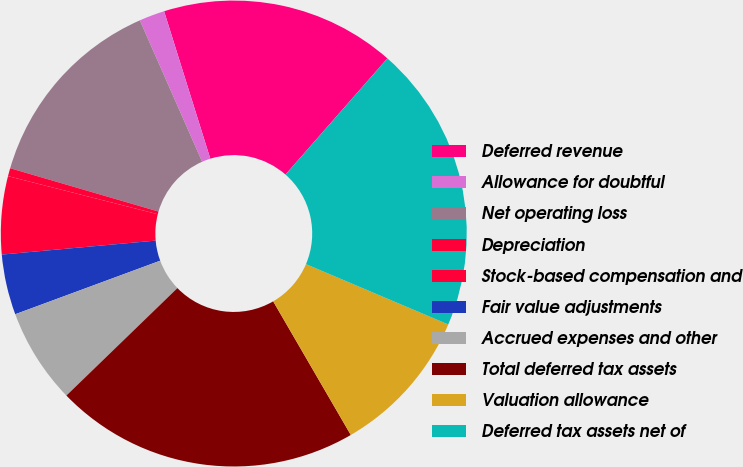Convert chart to OTSL. <chart><loc_0><loc_0><loc_500><loc_500><pie_chart><fcel>Deferred revenue<fcel>Allowance for doubtful<fcel>Net operating loss<fcel>Depreciation<fcel>Stock-based compensation and<fcel>Fair value adjustments<fcel>Accrued expenses and other<fcel>Total deferred tax assets<fcel>Valuation allowance<fcel>Deferred tax assets net of<nl><fcel>16.29%<fcel>1.77%<fcel>13.87%<fcel>0.56%<fcel>5.4%<fcel>4.19%<fcel>6.61%<fcel>21.13%<fcel>10.24%<fcel>19.92%<nl></chart> 